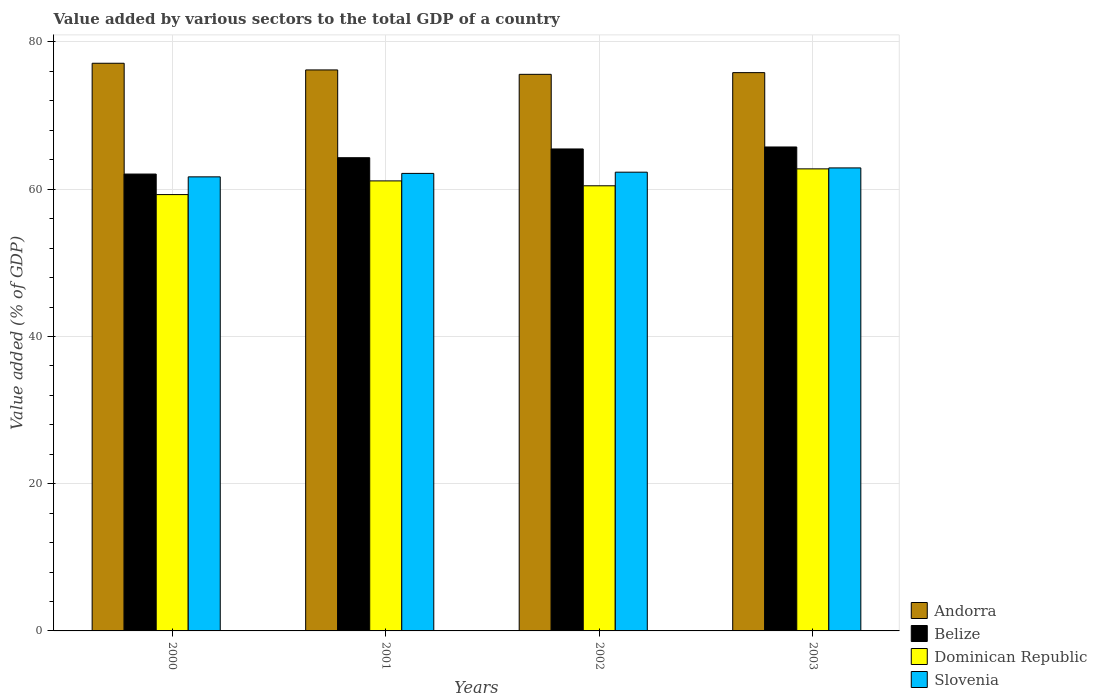How many groups of bars are there?
Make the answer very short. 4. Are the number of bars per tick equal to the number of legend labels?
Offer a very short reply. Yes. Are the number of bars on each tick of the X-axis equal?
Your answer should be very brief. Yes. How many bars are there on the 4th tick from the left?
Provide a succinct answer. 4. How many bars are there on the 4th tick from the right?
Offer a terse response. 4. What is the value added by various sectors to the total GDP in Andorra in 2003?
Offer a terse response. 75.84. Across all years, what is the maximum value added by various sectors to the total GDP in Slovenia?
Offer a terse response. 62.9. Across all years, what is the minimum value added by various sectors to the total GDP in Andorra?
Keep it short and to the point. 75.6. What is the total value added by various sectors to the total GDP in Slovenia in the graph?
Your answer should be very brief. 249.04. What is the difference between the value added by various sectors to the total GDP in Slovenia in 2002 and that in 2003?
Provide a short and direct response. -0.58. What is the difference between the value added by various sectors to the total GDP in Dominican Republic in 2003 and the value added by various sectors to the total GDP in Slovenia in 2002?
Your response must be concise. 0.45. What is the average value added by various sectors to the total GDP in Slovenia per year?
Give a very brief answer. 62.26. In the year 2001, what is the difference between the value added by various sectors to the total GDP in Andorra and value added by various sectors to the total GDP in Belize?
Offer a very short reply. 11.92. What is the ratio of the value added by various sectors to the total GDP in Belize in 2002 to that in 2003?
Your answer should be compact. 1. Is the value added by various sectors to the total GDP in Dominican Republic in 2000 less than that in 2001?
Keep it short and to the point. Yes. Is the difference between the value added by various sectors to the total GDP in Andorra in 2000 and 2003 greater than the difference between the value added by various sectors to the total GDP in Belize in 2000 and 2003?
Make the answer very short. Yes. What is the difference between the highest and the second highest value added by various sectors to the total GDP in Andorra?
Ensure brevity in your answer.  0.91. What is the difference between the highest and the lowest value added by various sectors to the total GDP in Dominican Republic?
Provide a succinct answer. 3.49. In how many years, is the value added by various sectors to the total GDP in Slovenia greater than the average value added by various sectors to the total GDP in Slovenia taken over all years?
Your answer should be very brief. 2. Is it the case that in every year, the sum of the value added by various sectors to the total GDP in Andorra and value added by various sectors to the total GDP in Belize is greater than the sum of value added by various sectors to the total GDP in Slovenia and value added by various sectors to the total GDP in Dominican Republic?
Give a very brief answer. Yes. What does the 2nd bar from the left in 2003 represents?
Your answer should be very brief. Belize. What does the 1st bar from the right in 2001 represents?
Give a very brief answer. Slovenia. Is it the case that in every year, the sum of the value added by various sectors to the total GDP in Belize and value added by various sectors to the total GDP in Slovenia is greater than the value added by various sectors to the total GDP in Andorra?
Give a very brief answer. Yes. How many bars are there?
Ensure brevity in your answer.  16. How many years are there in the graph?
Your response must be concise. 4. What is the difference between two consecutive major ticks on the Y-axis?
Give a very brief answer. 20. Does the graph contain any zero values?
Give a very brief answer. No. Where does the legend appear in the graph?
Offer a very short reply. Bottom right. How are the legend labels stacked?
Your response must be concise. Vertical. What is the title of the graph?
Provide a short and direct response. Value added by various sectors to the total GDP of a country. Does "Turkmenistan" appear as one of the legend labels in the graph?
Provide a succinct answer. No. What is the label or title of the X-axis?
Ensure brevity in your answer.  Years. What is the label or title of the Y-axis?
Your answer should be compact. Value added (% of GDP). What is the Value added (% of GDP) in Andorra in 2000?
Provide a short and direct response. 77.11. What is the Value added (% of GDP) of Belize in 2000?
Offer a terse response. 62.06. What is the Value added (% of GDP) in Dominican Republic in 2000?
Your answer should be very brief. 59.27. What is the Value added (% of GDP) in Slovenia in 2000?
Your response must be concise. 61.68. What is the Value added (% of GDP) in Andorra in 2001?
Offer a very short reply. 76.21. What is the Value added (% of GDP) of Belize in 2001?
Keep it short and to the point. 64.28. What is the Value added (% of GDP) in Dominican Republic in 2001?
Make the answer very short. 61.13. What is the Value added (% of GDP) of Slovenia in 2001?
Provide a succinct answer. 62.15. What is the Value added (% of GDP) in Andorra in 2002?
Your response must be concise. 75.6. What is the Value added (% of GDP) in Belize in 2002?
Your answer should be compact. 65.47. What is the Value added (% of GDP) of Dominican Republic in 2002?
Offer a very short reply. 60.47. What is the Value added (% of GDP) of Slovenia in 2002?
Provide a short and direct response. 62.32. What is the Value added (% of GDP) of Andorra in 2003?
Give a very brief answer. 75.84. What is the Value added (% of GDP) in Belize in 2003?
Make the answer very short. 65.74. What is the Value added (% of GDP) of Dominican Republic in 2003?
Offer a very short reply. 62.76. What is the Value added (% of GDP) of Slovenia in 2003?
Offer a terse response. 62.9. Across all years, what is the maximum Value added (% of GDP) in Andorra?
Make the answer very short. 77.11. Across all years, what is the maximum Value added (% of GDP) of Belize?
Provide a short and direct response. 65.74. Across all years, what is the maximum Value added (% of GDP) of Dominican Republic?
Your response must be concise. 62.76. Across all years, what is the maximum Value added (% of GDP) in Slovenia?
Make the answer very short. 62.9. Across all years, what is the minimum Value added (% of GDP) in Andorra?
Provide a succinct answer. 75.6. Across all years, what is the minimum Value added (% of GDP) in Belize?
Offer a very short reply. 62.06. Across all years, what is the minimum Value added (% of GDP) of Dominican Republic?
Give a very brief answer. 59.27. Across all years, what is the minimum Value added (% of GDP) in Slovenia?
Your answer should be very brief. 61.68. What is the total Value added (% of GDP) in Andorra in the graph?
Offer a very short reply. 304.76. What is the total Value added (% of GDP) of Belize in the graph?
Keep it short and to the point. 257.55. What is the total Value added (% of GDP) in Dominican Republic in the graph?
Provide a succinct answer. 243.63. What is the total Value added (% of GDP) in Slovenia in the graph?
Your answer should be compact. 249.04. What is the difference between the Value added (% of GDP) in Andorra in 2000 and that in 2001?
Provide a succinct answer. 0.91. What is the difference between the Value added (% of GDP) of Belize in 2000 and that in 2001?
Make the answer very short. -2.22. What is the difference between the Value added (% of GDP) of Dominican Republic in 2000 and that in 2001?
Provide a short and direct response. -1.86. What is the difference between the Value added (% of GDP) of Slovenia in 2000 and that in 2001?
Your answer should be compact. -0.47. What is the difference between the Value added (% of GDP) of Andorra in 2000 and that in 2002?
Your answer should be very brief. 1.51. What is the difference between the Value added (% of GDP) in Belize in 2000 and that in 2002?
Keep it short and to the point. -3.41. What is the difference between the Value added (% of GDP) of Dominican Republic in 2000 and that in 2002?
Your answer should be very brief. -1.2. What is the difference between the Value added (% of GDP) of Slovenia in 2000 and that in 2002?
Offer a terse response. -0.64. What is the difference between the Value added (% of GDP) in Andorra in 2000 and that in 2003?
Provide a succinct answer. 1.27. What is the difference between the Value added (% of GDP) of Belize in 2000 and that in 2003?
Provide a short and direct response. -3.68. What is the difference between the Value added (% of GDP) in Dominican Republic in 2000 and that in 2003?
Offer a very short reply. -3.49. What is the difference between the Value added (% of GDP) of Slovenia in 2000 and that in 2003?
Your response must be concise. -1.22. What is the difference between the Value added (% of GDP) in Andorra in 2001 and that in 2002?
Your answer should be compact. 0.6. What is the difference between the Value added (% of GDP) of Belize in 2001 and that in 2002?
Ensure brevity in your answer.  -1.19. What is the difference between the Value added (% of GDP) of Dominican Republic in 2001 and that in 2002?
Your answer should be compact. 0.66. What is the difference between the Value added (% of GDP) in Slovenia in 2001 and that in 2002?
Keep it short and to the point. -0.17. What is the difference between the Value added (% of GDP) of Andorra in 2001 and that in 2003?
Make the answer very short. 0.37. What is the difference between the Value added (% of GDP) of Belize in 2001 and that in 2003?
Ensure brevity in your answer.  -1.46. What is the difference between the Value added (% of GDP) in Dominican Republic in 2001 and that in 2003?
Give a very brief answer. -1.64. What is the difference between the Value added (% of GDP) in Slovenia in 2001 and that in 2003?
Offer a very short reply. -0.75. What is the difference between the Value added (% of GDP) in Andorra in 2002 and that in 2003?
Offer a very short reply. -0.23. What is the difference between the Value added (% of GDP) of Belize in 2002 and that in 2003?
Provide a succinct answer. -0.27. What is the difference between the Value added (% of GDP) in Dominican Republic in 2002 and that in 2003?
Keep it short and to the point. -2.3. What is the difference between the Value added (% of GDP) of Slovenia in 2002 and that in 2003?
Offer a terse response. -0.58. What is the difference between the Value added (% of GDP) in Andorra in 2000 and the Value added (% of GDP) in Belize in 2001?
Your answer should be very brief. 12.83. What is the difference between the Value added (% of GDP) of Andorra in 2000 and the Value added (% of GDP) of Dominican Republic in 2001?
Ensure brevity in your answer.  15.98. What is the difference between the Value added (% of GDP) in Andorra in 2000 and the Value added (% of GDP) in Slovenia in 2001?
Provide a short and direct response. 14.96. What is the difference between the Value added (% of GDP) of Belize in 2000 and the Value added (% of GDP) of Dominican Republic in 2001?
Offer a terse response. 0.93. What is the difference between the Value added (% of GDP) of Belize in 2000 and the Value added (% of GDP) of Slovenia in 2001?
Give a very brief answer. -0.09. What is the difference between the Value added (% of GDP) in Dominican Republic in 2000 and the Value added (% of GDP) in Slovenia in 2001?
Ensure brevity in your answer.  -2.88. What is the difference between the Value added (% of GDP) in Andorra in 2000 and the Value added (% of GDP) in Belize in 2002?
Your answer should be compact. 11.64. What is the difference between the Value added (% of GDP) in Andorra in 2000 and the Value added (% of GDP) in Dominican Republic in 2002?
Provide a succinct answer. 16.64. What is the difference between the Value added (% of GDP) of Andorra in 2000 and the Value added (% of GDP) of Slovenia in 2002?
Offer a terse response. 14.8. What is the difference between the Value added (% of GDP) of Belize in 2000 and the Value added (% of GDP) of Dominican Republic in 2002?
Your answer should be compact. 1.59. What is the difference between the Value added (% of GDP) of Belize in 2000 and the Value added (% of GDP) of Slovenia in 2002?
Your answer should be very brief. -0.26. What is the difference between the Value added (% of GDP) of Dominican Republic in 2000 and the Value added (% of GDP) of Slovenia in 2002?
Your response must be concise. -3.05. What is the difference between the Value added (% of GDP) in Andorra in 2000 and the Value added (% of GDP) in Belize in 2003?
Provide a short and direct response. 11.37. What is the difference between the Value added (% of GDP) of Andorra in 2000 and the Value added (% of GDP) of Dominican Republic in 2003?
Offer a terse response. 14.35. What is the difference between the Value added (% of GDP) of Andorra in 2000 and the Value added (% of GDP) of Slovenia in 2003?
Offer a very short reply. 14.22. What is the difference between the Value added (% of GDP) in Belize in 2000 and the Value added (% of GDP) in Dominican Republic in 2003?
Provide a short and direct response. -0.71. What is the difference between the Value added (% of GDP) of Belize in 2000 and the Value added (% of GDP) of Slovenia in 2003?
Keep it short and to the point. -0.84. What is the difference between the Value added (% of GDP) in Dominican Republic in 2000 and the Value added (% of GDP) in Slovenia in 2003?
Your answer should be compact. -3.62. What is the difference between the Value added (% of GDP) in Andorra in 2001 and the Value added (% of GDP) in Belize in 2002?
Your answer should be very brief. 10.74. What is the difference between the Value added (% of GDP) of Andorra in 2001 and the Value added (% of GDP) of Dominican Republic in 2002?
Offer a terse response. 15.74. What is the difference between the Value added (% of GDP) in Andorra in 2001 and the Value added (% of GDP) in Slovenia in 2002?
Your response must be concise. 13.89. What is the difference between the Value added (% of GDP) in Belize in 2001 and the Value added (% of GDP) in Dominican Republic in 2002?
Provide a short and direct response. 3.81. What is the difference between the Value added (% of GDP) in Belize in 2001 and the Value added (% of GDP) in Slovenia in 2002?
Your answer should be very brief. 1.97. What is the difference between the Value added (% of GDP) in Dominican Republic in 2001 and the Value added (% of GDP) in Slovenia in 2002?
Make the answer very short. -1.19. What is the difference between the Value added (% of GDP) of Andorra in 2001 and the Value added (% of GDP) of Belize in 2003?
Your response must be concise. 10.47. What is the difference between the Value added (% of GDP) in Andorra in 2001 and the Value added (% of GDP) in Dominican Republic in 2003?
Provide a succinct answer. 13.44. What is the difference between the Value added (% of GDP) of Andorra in 2001 and the Value added (% of GDP) of Slovenia in 2003?
Provide a succinct answer. 13.31. What is the difference between the Value added (% of GDP) in Belize in 2001 and the Value added (% of GDP) in Dominican Republic in 2003?
Your response must be concise. 1.52. What is the difference between the Value added (% of GDP) of Belize in 2001 and the Value added (% of GDP) of Slovenia in 2003?
Offer a terse response. 1.39. What is the difference between the Value added (% of GDP) of Dominican Republic in 2001 and the Value added (% of GDP) of Slovenia in 2003?
Ensure brevity in your answer.  -1.77. What is the difference between the Value added (% of GDP) of Andorra in 2002 and the Value added (% of GDP) of Belize in 2003?
Offer a terse response. 9.87. What is the difference between the Value added (% of GDP) in Andorra in 2002 and the Value added (% of GDP) in Dominican Republic in 2003?
Your response must be concise. 12.84. What is the difference between the Value added (% of GDP) of Andorra in 2002 and the Value added (% of GDP) of Slovenia in 2003?
Your response must be concise. 12.71. What is the difference between the Value added (% of GDP) in Belize in 2002 and the Value added (% of GDP) in Dominican Republic in 2003?
Provide a short and direct response. 2.7. What is the difference between the Value added (% of GDP) in Belize in 2002 and the Value added (% of GDP) in Slovenia in 2003?
Ensure brevity in your answer.  2.57. What is the difference between the Value added (% of GDP) in Dominican Republic in 2002 and the Value added (% of GDP) in Slovenia in 2003?
Provide a succinct answer. -2.43. What is the average Value added (% of GDP) in Andorra per year?
Offer a terse response. 76.19. What is the average Value added (% of GDP) in Belize per year?
Offer a very short reply. 64.39. What is the average Value added (% of GDP) in Dominican Republic per year?
Make the answer very short. 60.91. What is the average Value added (% of GDP) in Slovenia per year?
Give a very brief answer. 62.26. In the year 2000, what is the difference between the Value added (% of GDP) of Andorra and Value added (% of GDP) of Belize?
Keep it short and to the point. 15.05. In the year 2000, what is the difference between the Value added (% of GDP) of Andorra and Value added (% of GDP) of Dominican Republic?
Give a very brief answer. 17.84. In the year 2000, what is the difference between the Value added (% of GDP) of Andorra and Value added (% of GDP) of Slovenia?
Provide a succinct answer. 15.43. In the year 2000, what is the difference between the Value added (% of GDP) of Belize and Value added (% of GDP) of Dominican Republic?
Ensure brevity in your answer.  2.79. In the year 2000, what is the difference between the Value added (% of GDP) in Belize and Value added (% of GDP) in Slovenia?
Your answer should be very brief. 0.38. In the year 2000, what is the difference between the Value added (% of GDP) of Dominican Republic and Value added (% of GDP) of Slovenia?
Provide a succinct answer. -2.41. In the year 2001, what is the difference between the Value added (% of GDP) in Andorra and Value added (% of GDP) in Belize?
Offer a very short reply. 11.92. In the year 2001, what is the difference between the Value added (% of GDP) in Andorra and Value added (% of GDP) in Dominican Republic?
Your answer should be very brief. 15.08. In the year 2001, what is the difference between the Value added (% of GDP) in Andorra and Value added (% of GDP) in Slovenia?
Offer a terse response. 14.06. In the year 2001, what is the difference between the Value added (% of GDP) of Belize and Value added (% of GDP) of Dominican Republic?
Keep it short and to the point. 3.15. In the year 2001, what is the difference between the Value added (% of GDP) in Belize and Value added (% of GDP) in Slovenia?
Your response must be concise. 2.13. In the year 2001, what is the difference between the Value added (% of GDP) in Dominican Republic and Value added (% of GDP) in Slovenia?
Give a very brief answer. -1.02. In the year 2002, what is the difference between the Value added (% of GDP) in Andorra and Value added (% of GDP) in Belize?
Give a very brief answer. 10.14. In the year 2002, what is the difference between the Value added (% of GDP) of Andorra and Value added (% of GDP) of Dominican Republic?
Your answer should be compact. 15.14. In the year 2002, what is the difference between the Value added (% of GDP) of Andorra and Value added (% of GDP) of Slovenia?
Make the answer very short. 13.29. In the year 2002, what is the difference between the Value added (% of GDP) in Belize and Value added (% of GDP) in Dominican Republic?
Your response must be concise. 5. In the year 2002, what is the difference between the Value added (% of GDP) of Belize and Value added (% of GDP) of Slovenia?
Provide a succinct answer. 3.15. In the year 2002, what is the difference between the Value added (% of GDP) in Dominican Republic and Value added (% of GDP) in Slovenia?
Offer a very short reply. -1.85. In the year 2003, what is the difference between the Value added (% of GDP) of Andorra and Value added (% of GDP) of Belize?
Provide a succinct answer. 10.1. In the year 2003, what is the difference between the Value added (% of GDP) in Andorra and Value added (% of GDP) in Dominican Republic?
Keep it short and to the point. 13.07. In the year 2003, what is the difference between the Value added (% of GDP) in Andorra and Value added (% of GDP) in Slovenia?
Ensure brevity in your answer.  12.94. In the year 2003, what is the difference between the Value added (% of GDP) of Belize and Value added (% of GDP) of Dominican Republic?
Provide a short and direct response. 2.97. In the year 2003, what is the difference between the Value added (% of GDP) of Belize and Value added (% of GDP) of Slovenia?
Ensure brevity in your answer.  2.84. In the year 2003, what is the difference between the Value added (% of GDP) of Dominican Republic and Value added (% of GDP) of Slovenia?
Ensure brevity in your answer.  -0.13. What is the ratio of the Value added (% of GDP) of Andorra in 2000 to that in 2001?
Offer a terse response. 1.01. What is the ratio of the Value added (% of GDP) in Belize in 2000 to that in 2001?
Provide a short and direct response. 0.97. What is the ratio of the Value added (% of GDP) of Dominican Republic in 2000 to that in 2001?
Your answer should be very brief. 0.97. What is the ratio of the Value added (% of GDP) in Slovenia in 2000 to that in 2001?
Provide a succinct answer. 0.99. What is the ratio of the Value added (% of GDP) of Andorra in 2000 to that in 2002?
Give a very brief answer. 1.02. What is the ratio of the Value added (% of GDP) of Belize in 2000 to that in 2002?
Your response must be concise. 0.95. What is the ratio of the Value added (% of GDP) in Dominican Republic in 2000 to that in 2002?
Keep it short and to the point. 0.98. What is the ratio of the Value added (% of GDP) in Slovenia in 2000 to that in 2002?
Keep it short and to the point. 0.99. What is the ratio of the Value added (% of GDP) in Andorra in 2000 to that in 2003?
Your response must be concise. 1.02. What is the ratio of the Value added (% of GDP) in Belize in 2000 to that in 2003?
Make the answer very short. 0.94. What is the ratio of the Value added (% of GDP) in Dominican Republic in 2000 to that in 2003?
Offer a terse response. 0.94. What is the ratio of the Value added (% of GDP) of Slovenia in 2000 to that in 2003?
Make the answer very short. 0.98. What is the ratio of the Value added (% of GDP) of Andorra in 2001 to that in 2002?
Offer a very short reply. 1.01. What is the ratio of the Value added (% of GDP) of Belize in 2001 to that in 2002?
Offer a very short reply. 0.98. What is the ratio of the Value added (% of GDP) of Dominican Republic in 2001 to that in 2002?
Ensure brevity in your answer.  1.01. What is the ratio of the Value added (% of GDP) in Andorra in 2001 to that in 2003?
Your answer should be very brief. 1. What is the ratio of the Value added (% of GDP) of Belize in 2001 to that in 2003?
Your answer should be very brief. 0.98. What is the ratio of the Value added (% of GDP) of Dominican Republic in 2001 to that in 2003?
Make the answer very short. 0.97. What is the ratio of the Value added (% of GDP) in Belize in 2002 to that in 2003?
Give a very brief answer. 1. What is the ratio of the Value added (% of GDP) of Dominican Republic in 2002 to that in 2003?
Offer a very short reply. 0.96. What is the difference between the highest and the second highest Value added (% of GDP) in Andorra?
Offer a very short reply. 0.91. What is the difference between the highest and the second highest Value added (% of GDP) of Belize?
Keep it short and to the point. 0.27. What is the difference between the highest and the second highest Value added (% of GDP) of Dominican Republic?
Offer a terse response. 1.64. What is the difference between the highest and the second highest Value added (% of GDP) in Slovenia?
Your response must be concise. 0.58. What is the difference between the highest and the lowest Value added (% of GDP) in Andorra?
Offer a terse response. 1.51. What is the difference between the highest and the lowest Value added (% of GDP) of Belize?
Ensure brevity in your answer.  3.68. What is the difference between the highest and the lowest Value added (% of GDP) of Dominican Republic?
Provide a succinct answer. 3.49. What is the difference between the highest and the lowest Value added (% of GDP) in Slovenia?
Keep it short and to the point. 1.22. 